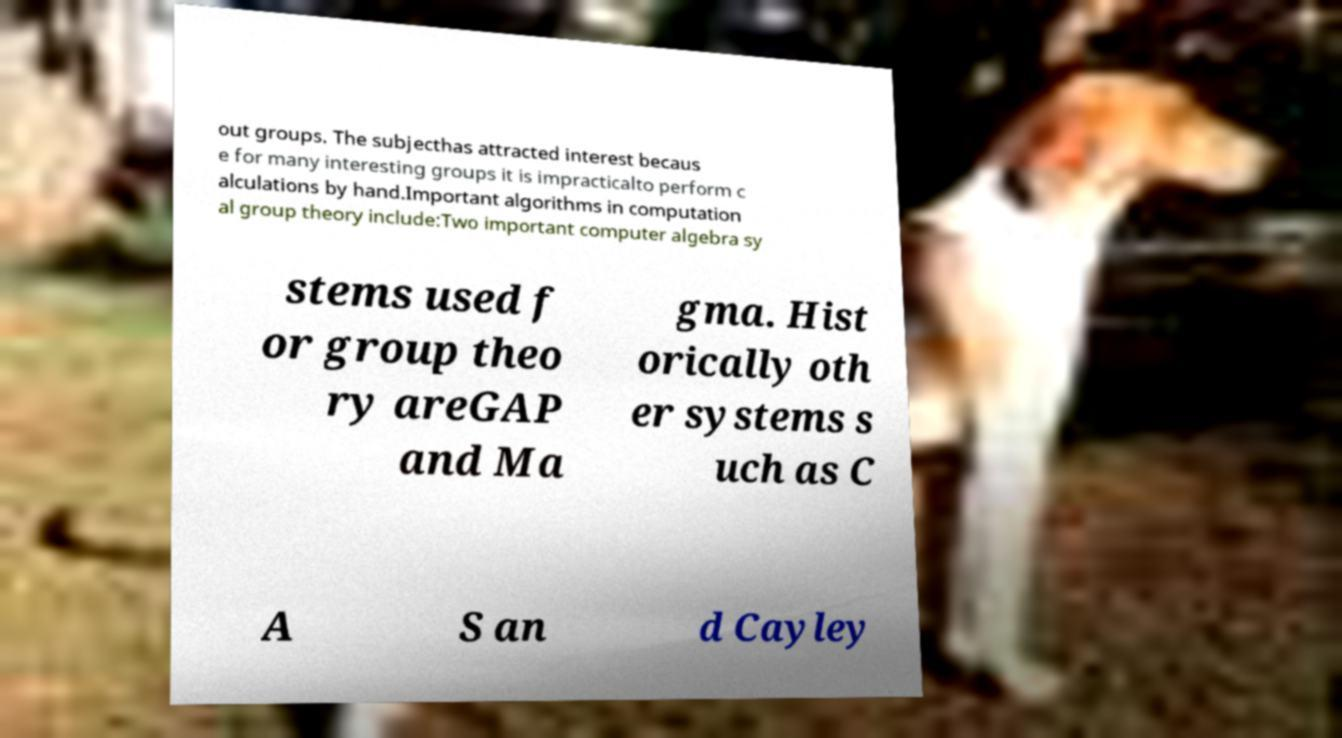Can you accurately transcribe the text from the provided image for me? out groups. The subjecthas attracted interest becaus e for many interesting groups it is impracticalto perform c alculations by hand.Important algorithms in computation al group theory include:Two important computer algebra sy stems used f or group theo ry areGAP and Ma gma. Hist orically oth er systems s uch as C A S an d Cayley 